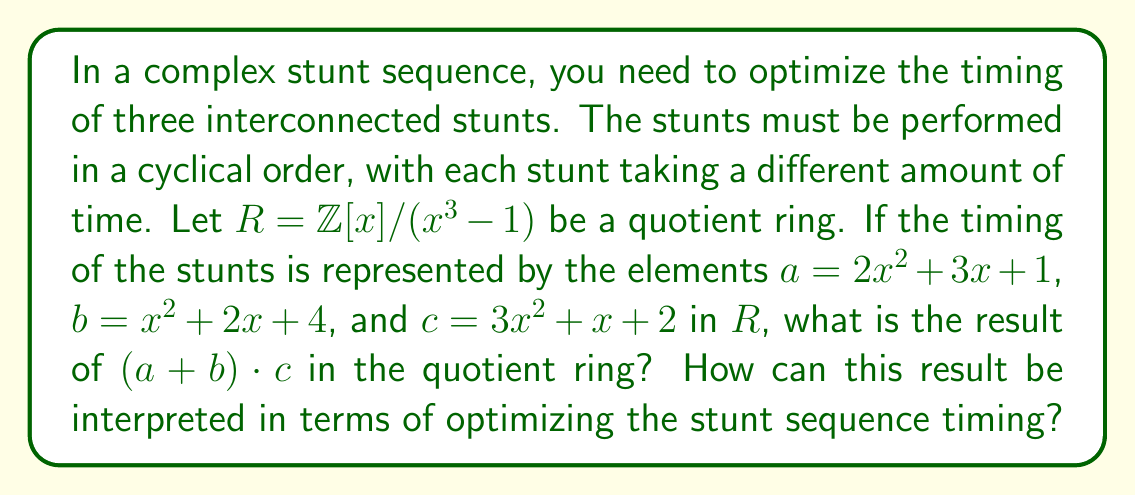Solve this math problem. Let's approach this step-by-step:

1) First, we need to understand what the quotient ring $R = \mathbb{Z}[x]/(x^3 - 1)$ means. In this ring, $x^3 \equiv 1$, or equivalently, $x^3 - 1 \equiv 0$.

2) Let's calculate $a + b$:
   $a + b = (2x^2 + 3x + 1) + (x^2 + 2x + 4) = 3x^2 + 5x + 5$

3) Now we need to multiply $(a + b)$ by $c$:
   $(3x^2 + 5x + 5) \cdot (3x^2 + x + 2)$

4) Let's expand this:
   $9x^4 + 3x^3 + 6x^2 + 15x^3 + 5x^2 + 10x + 15x^2 + 5x + 10$

5) Simplify:
   $9x^4 + 18x^3 + 26x^2 + 15x + 10$

6) In our quotient ring, $x^3 \equiv 1$, so $x^4 \equiv x$. Let's apply this:
   $9x + 18 + 26x^2 + 15x + 10$

7) Simplify further:
   $26x^2 + 24x + 28$

Therefore, $(a + b) \cdot c \equiv 26x^2 + 24x + 28$ in $R$.

Interpretation for stunt timing:
In this context, the powers of $x$ can be interpreted as different stunts in the sequence (x^0 for the first stunt, x^1 for the second, and x^2 for the third). The coefficients represent the timing or duration of each stunt.

The result $26x^2 + 24x + 28$ suggests an optimized timing where:
- The third stunt (x^2) should take 26 time units
- The second stunt (x) should take 24 time units
- The first stunt (constant term) should take 28 time units

This calculation helps balance the timing across the stunt sequence, considering the interconnected nature of the stunts represented by the ring structure.
Answer: $(a + b) \cdot c \equiv 26x^2 + 24x + 28$ in $R = \mathbb{Z}[x]/(x^3 - 1)$ 